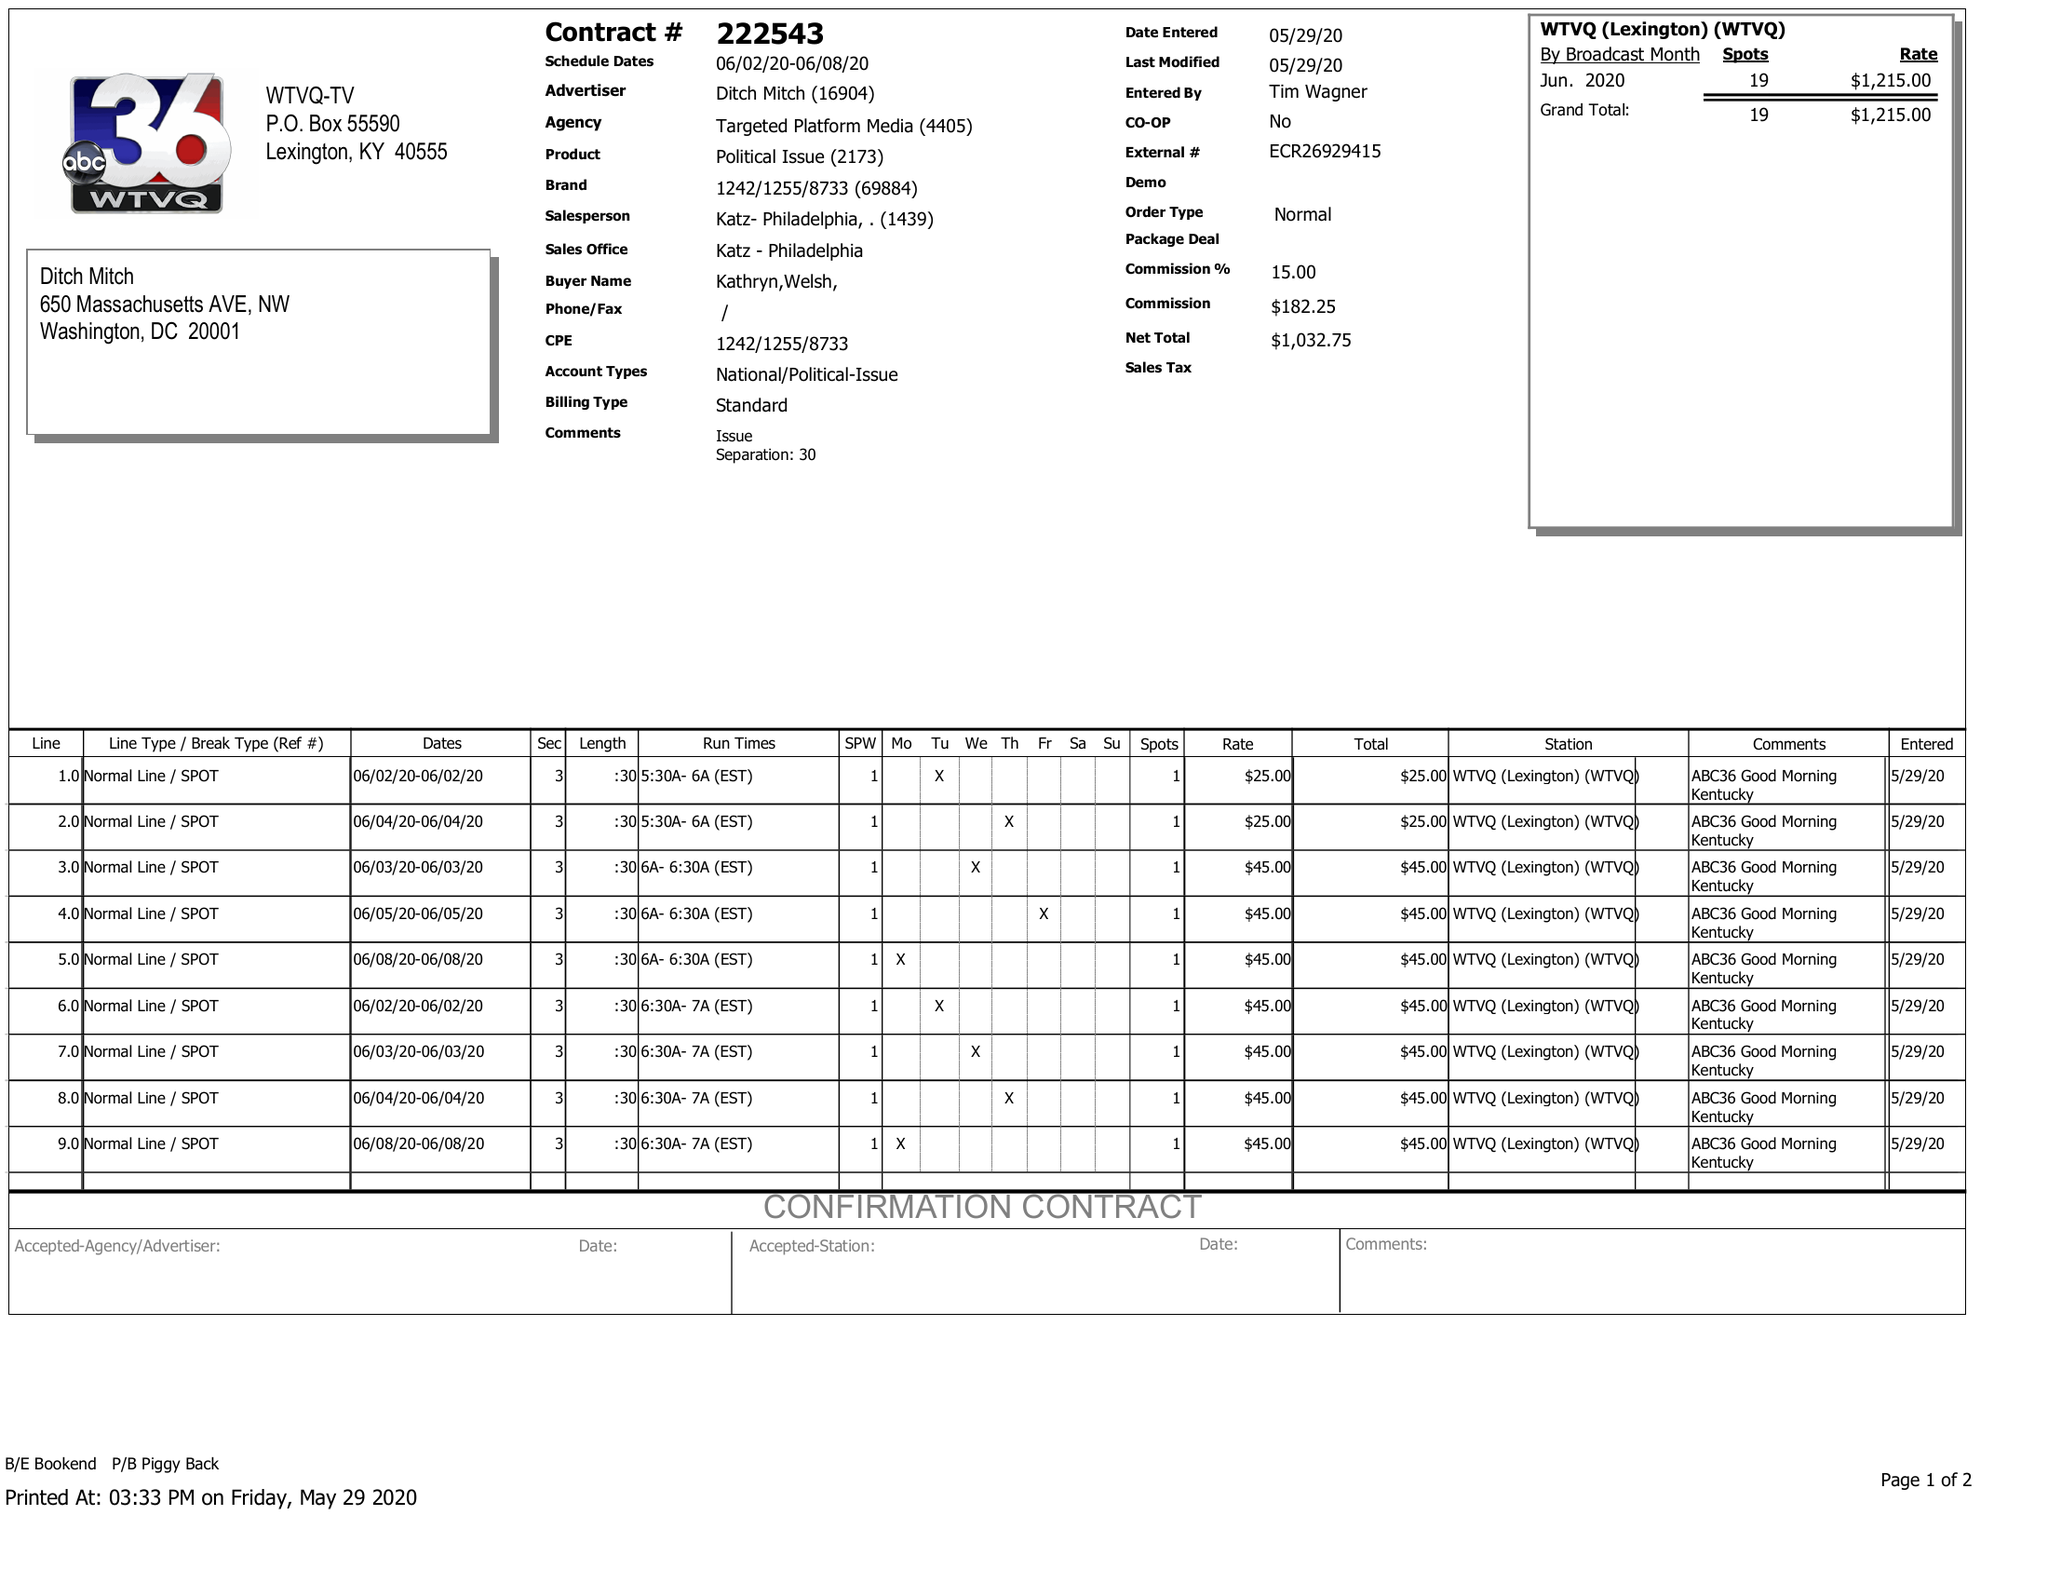What is the value for the flight_to?
Answer the question using a single word or phrase. 06/08/20 